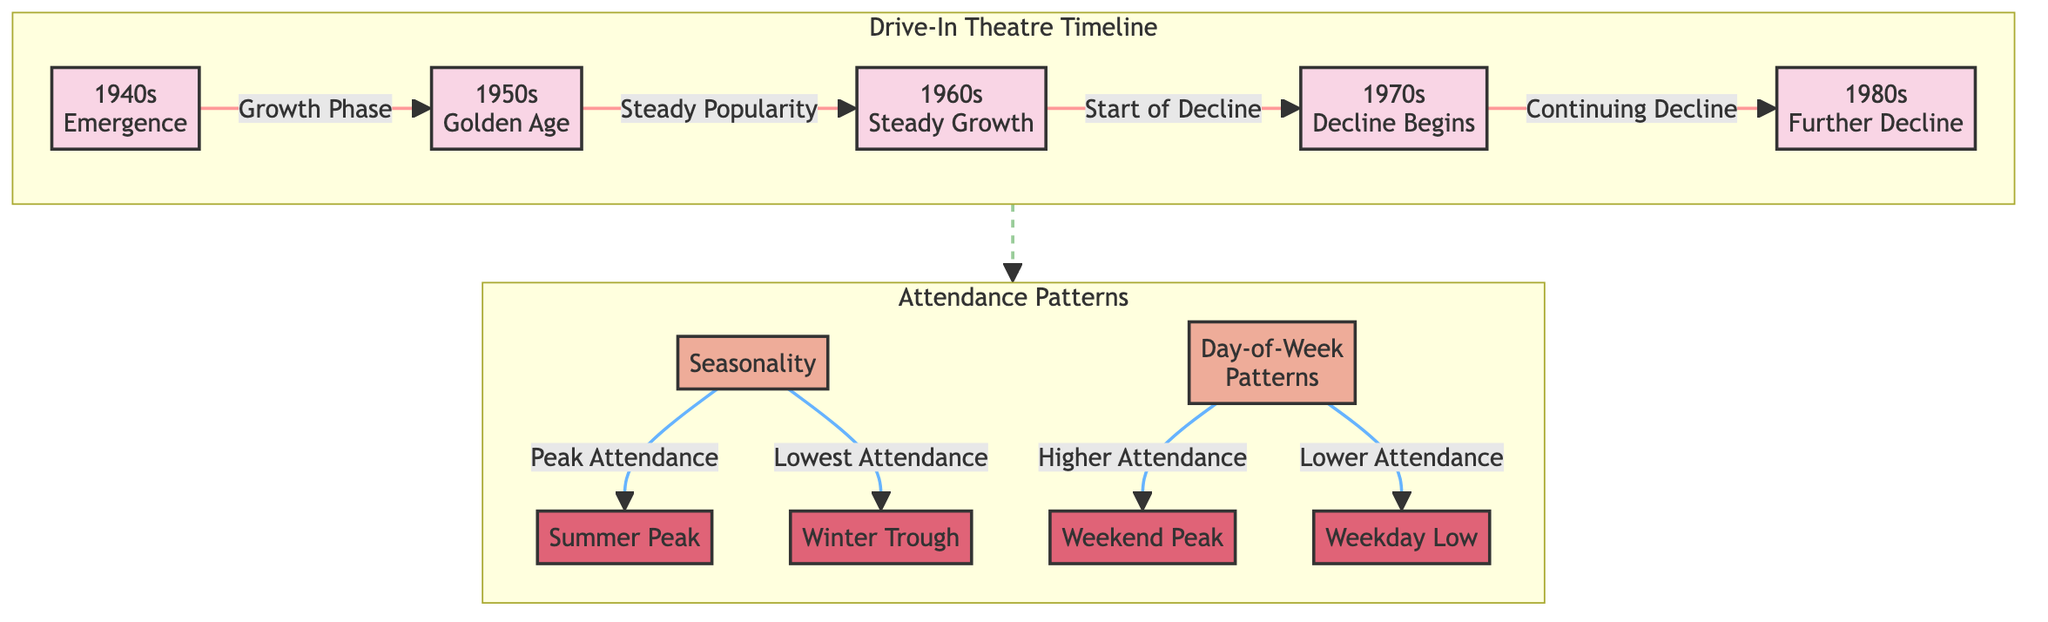What decade marks the emergence of drive-in theaters? The diagram indicates that drive-in theaters emerged in the 1940s. This is shown as the starting point of the timeline for drive-in theaters.
Answer: 1940s Which decade is identified as the Golden Age of drive-in theaters? According to the diagram, the 1950s are labeled as the Golden Age, directly connected to the emergence in the 1940s, highlighting a peak phase in attendance.
Answer: 1950s What season shows peak attendance for drive-in theaters? The diagram explicitly states that summer is the season with peak attendance, indicating that warmer weather attracts more patrons to drive-in theaters.
Answer: Summer What season has the lowest attendance according to the diagram? The diagram indicates winter as the season with the lowest attendance, reflecting a trough in the attendance patterns.
Answer: Winter Which day of the week generally sees higher attendance at drive-in theaters? The diagram highlights weekends as days that typically see higher attendance, suggesting that more people are likely to visit on these days compared to weekdays.
Answer: Weekend In which decade did the decline of drive-in theaters begin? The diagram shows that the decline began in the 1970s, linking it to a downward trend in attendance following the steady growth of previous decades.
Answer: 1970s What is the relationship between weekday and weekend attendance in the diagram? The diagram illustrates that weekend attendance is generally higher than weekday attendance, indicating a notable difference in viewing habits based on the day of the week.
Answer: Higher attendance on weekends How many decades are represented in the timeline of the diagram? The diagram lists five decades: 1940s, 1950s, 1960s, 1970s, and 1980s. By counting each labeled decade, we determine the total represented in the timeline.
Answer: Five What pattern is illustrated by the dotted line connecting the timeline to attendance patterns? The dotted line signifies a connection between the chronology of the drive-in theaters and the varying attendance patterns, indicating that historical trends influence current patterns.
Answer: Connection between timelines and patterns 